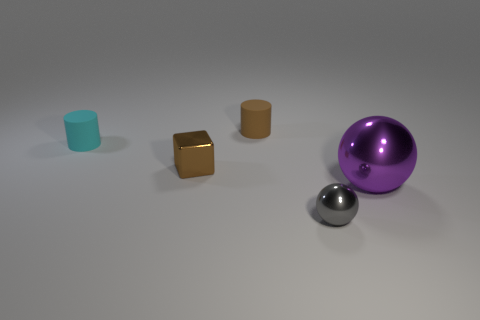Subtract all blocks. How many objects are left? 4 Add 3 large shiny things. How many objects exist? 8 Subtract all purple cylinders. How many cyan blocks are left? 0 Add 4 gray metal balls. How many gray metal balls exist? 5 Subtract 0 yellow spheres. How many objects are left? 5 Subtract 2 spheres. How many spheres are left? 0 Subtract all red cylinders. Subtract all red blocks. How many cylinders are left? 2 Subtract all cyan rubber cylinders. Subtract all metallic objects. How many objects are left? 1 Add 4 small objects. How many small objects are left? 8 